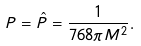Convert formula to latex. <formula><loc_0><loc_0><loc_500><loc_500>P = \hat { P } = \frac { 1 } { 7 6 8 \pi M ^ { 2 } } .</formula> 